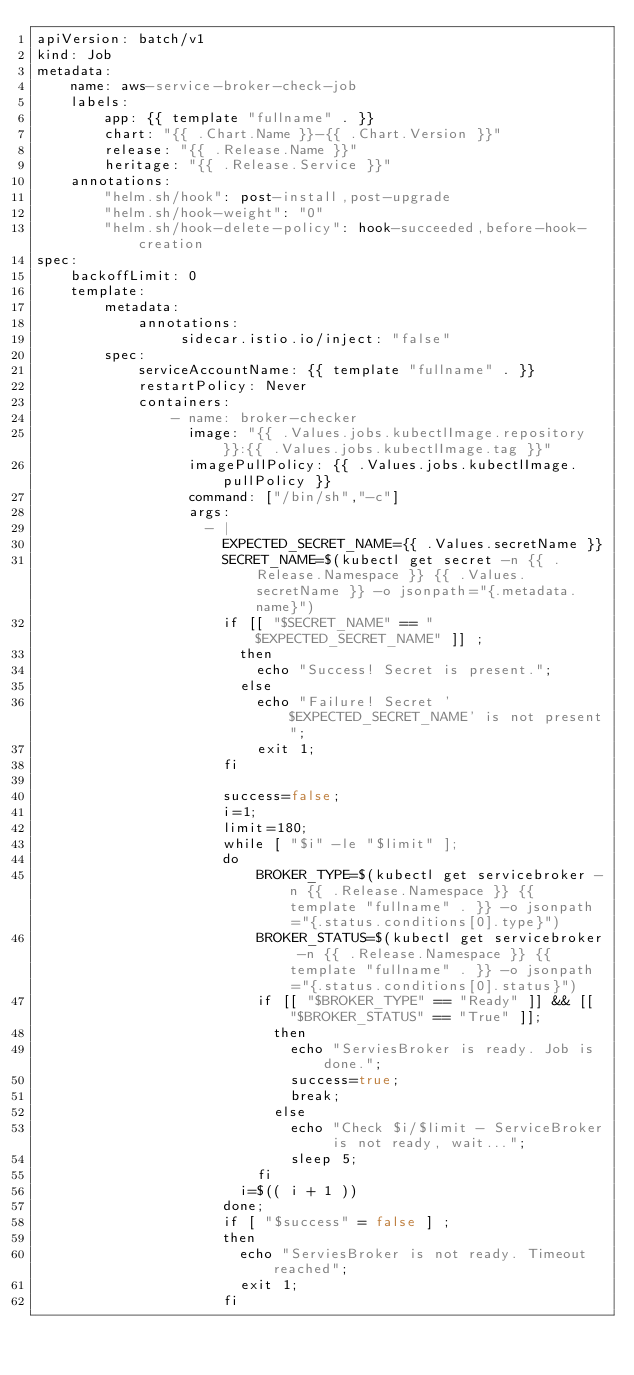Convert code to text. <code><loc_0><loc_0><loc_500><loc_500><_YAML_>apiVersion: batch/v1
kind: Job
metadata:
    name: aws-service-broker-check-job
    labels:
        app: {{ template "fullname" . }}
        chart: "{{ .Chart.Name }}-{{ .Chart.Version }}"
        release: "{{ .Release.Name }}"
        heritage: "{{ .Release.Service }}"
    annotations:
        "helm.sh/hook": post-install,post-upgrade
        "helm.sh/hook-weight": "0"
        "helm.sh/hook-delete-policy": hook-succeeded,before-hook-creation
spec:
    backoffLimit: 0
    template:
        metadata:
            annotations:
                 sidecar.istio.io/inject: "false"
        spec:
            serviceAccountName: {{ template "fullname" . }}
            restartPolicy: Never
            containers:
                - name: broker-checker
                  image: "{{ .Values.jobs.kubectlImage.repository }}:{{ .Values.jobs.kubectlImage.tag }}"
                  imagePullPolicy: {{ .Values.jobs.kubectlImage.pullPolicy }}
                  command: ["/bin/sh","-c"]
                  args:
                    - |
                      EXPECTED_SECRET_NAME={{ .Values.secretName }}
                      SECRET_NAME=$(kubectl get secret -n {{ .Release.Namespace }} {{ .Values.secretName }} -o jsonpath="{.metadata.name}")
                      if [[ "$SECRET_NAME" == "$EXPECTED_SECRET_NAME" ]] ;
                        then
                          echo "Success! Secret is present.";
                        else
                          echo "Failure! Secret '$EXPECTED_SECRET_NAME' is not present";
                          exit 1;
                      fi

                      success=false;
                      i=1;
                      limit=180;
                      while [ "$i" -le "$limit" ];
                      do
                          BROKER_TYPE=$(kubectl get servicebroker -n {{ .Release.Namespace }} {{ template "fullname" . }} -o jsonpath="{.status.conditions[0].type}")
                          BROKER_STATUS=$(kubectl get servicebroker -n {{ .Release.Namespace }} {{ template "fullname" . }} -o jsonpath="{.status.conditions[0].status}")
                          if [[ "$BROKER_TYPE" == "Ready" ]] && [[ "$BROKER_STATUS" == "True" ]];
                            then
                              echo "ServiesBroker is ready. Job is done.";
                              success=true;
                              break;
                            else
                              echo "Check $i/$limit - ServiceBroker is not ready, wait...";
                              sleep 5;
                          fi
                        i=$(( i + 1 ))
                      done;
                      if [ "$success" = false ] ;
                      then
                        echo "ServiesBroker is not ready. Timeout reached";
                        exit 1;
                      fi
</code> 